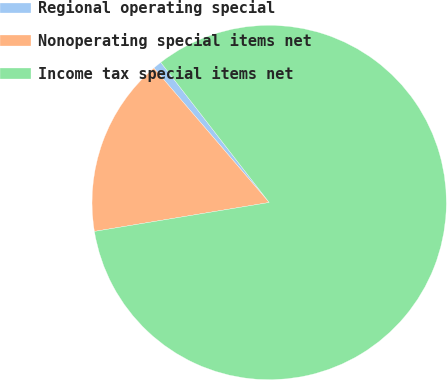<chart> <loc_0><loc_0><loc_500><loc_500><pie_chart><fcel>Regional operating special<fcel>Nonoperating special items net<fcel>Income tax special items net<nl><fcel>0.8%<fcel>16.33%<fcel>82.88%<nl></chart> 